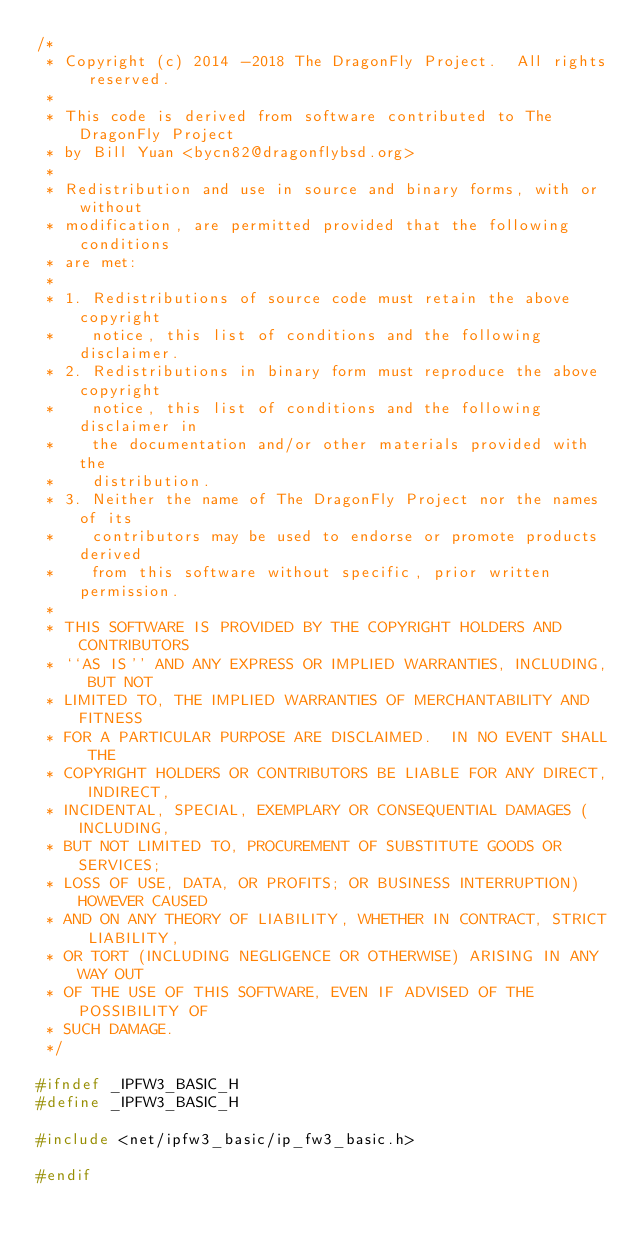<code> <loc_0><loc_0><loc_500><loc_500><_C_>/*
 * Copyright (c) 2014 -2018 The DragonFly Project.  All rights reserved.
 *
 * This code is derived from software contributed to The DragonFly Project
 * by Bill Yuan <bycn82@dragonflybsd.org>
 *
 * Redistribution and use in source and binary forms, with or without
 * modification, are permitted provided that the following conditions
 * are met:
 *
 * 1. Redistributions of source code must retain the above copyright
 *    notice, this list of conditions and the following disclaimer.
 * 2. Redistributions in binary form must reproduce the above copyright
 *    notice, this list of conditions and the following disclaimer in
 *    the documentation and/or other materials provided with the
 *    distribution.
 * 3. Neither the name of The DragonFly Project nor the names of its
 *    contributors may be used to endorse or promote products derived
 *    from this software without specific, prior written permission.
 *
 * THIS SOFTWARE IS PROVIDED BY THE COPYRIGHT HOLDERS AND CONTRIBUTORS
 * ``AS IS'' AND ANY EXPRESS OR IMPLIED WARRANTIES, INCLUDING, BUT NOT
 * LIMITED TO, THE IMPLIED WARRANTIES OF MERCHANTABILITY AND FITNESS
 * FOR A PARTICULAR PURPOSE ARE DISCLAIMED.  IN NO EVENT SHALL THE
 * COPYRIGHT HOLDERS OR CONTRIBUTORS BE LIABLE FOR ANY DIRECT, INDIRECT,
 * INCIDENTAL, SPECIAL, EXEMPLARY OR CONSEQUENTIAL DAMAGES (INCLUDING,
 * BUT NOT LIMITED TO, PROCUREMENT OF SUBSTITUTE GOODS OR SERVICES;
 * LOSS OF USE, DATA, OR PROFITS; OR BUSINESS INTERRUPTION) HOWEVER CAUSED
 * AND ON ANY THEORY OF LIABILITY, WHETHER IN CONTRACT, STRICT LIABILITY,
 * OR TORT (INCLUDING NEGLIGENCE OR OTHERWISE) ARISING IN ANY WAY OUT
 * OF THE USE OF THIS SOFTWARE, EVEN IF ADVISED OF THE POSSIBILITY OF
 * SUCH DAMAGE.
 */

#ifndef _IPFW3_BASIC_H
#define _IPFW3_BASIC_H

#include <net/ipfw3_basic/ip_fw3_basic.h>

#endif
</code> 